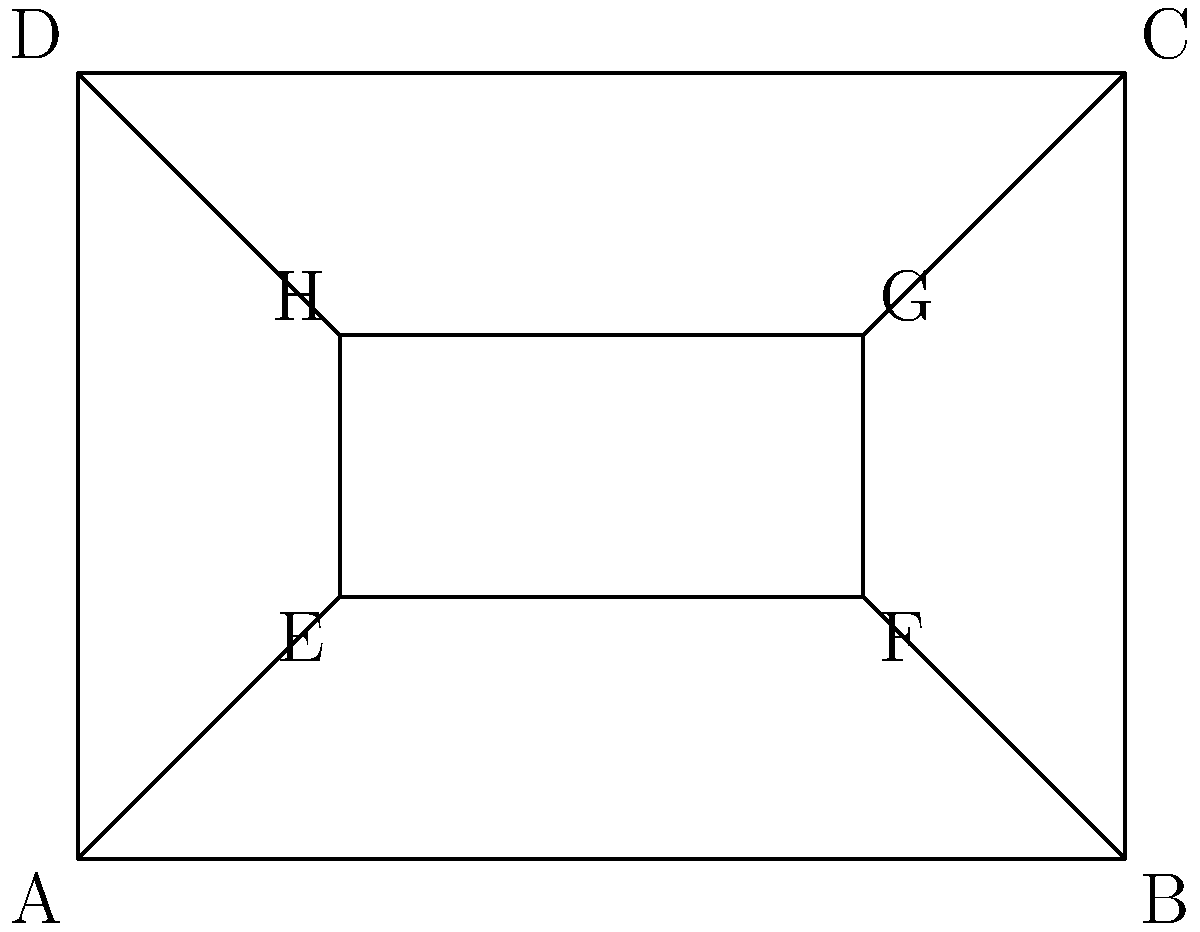In designing an optical illusion set piece for a pivotal scene in your psychological thriller, you want to create a forced perspective effect. The diagram shows a rectangular room with a smaller rectangle inside, representing a window. If the actual dimensions of the room are 8m x 6m x 4m (length x width x height), and the window appears to be perfectly centered and half the size of the wall when viewed from point A, what should be the actual dimensions (in meters) of the window to achieve this illusion? To solve this problem, we need to use the principles of perspective and similar triangles:

1) In the diagram, ABCD represents the wall, and EFGH represents the window.

2) For the window to appear centered and half the size of the wall when viewed from A, we need to calculate the ratios:

   $\frac{AE}{AB} = \frac{1}{4}$ and $\frac{EH}{AD} = \frac{1}{4}$

3) Given the actual dimensions:
   AB (length) = 8m
   AD (height) = 4m

4) To find the actual distance of the window from point A:
   $AE = \frac{1}{4} \times AB = \frac{1}{4} \times 8 = 2m$

5) To find the actual height of the window:
   $EH = \frac{1}{4} \times AD = \frac{1}{4} \times 4 = 1m$

6) To find the width of the window, we use the similar triangles ABD and EFH:

   $\frac{EF}{AB} = \frac{EH}{AD}$

   $EF = \frac{EH \times AB}{AD} = \frac{1 \times 8}{4} = 2m$

Therefore, the actual dimensions of the window should be 2m x 2m x 1m (length x width x height).
Answer: 2m x 2m x 1m 